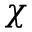Convert formula to latex. <formula><loc_0><loc_0><loc_500><loc_500>\chi</formula> 